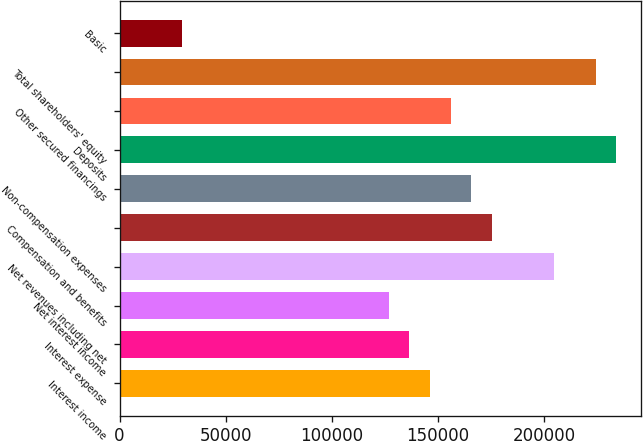<chart> <loc_0><loc_0><loc_500><loc_500><bar_chart><fcel>Interest income<fcel>Interest expense<fcel>Net interest income<fcel>Net revenues including net<fcel>Compensation and benefits<fcel>Non-compensation expenses<fcel>Deposits<fcel>Other secured financings<fcel>Total shareholders' equity<fcel>Basic<nl><fcel>146277<fcel>136526<fcel>126774<fcel>204787<fcel>175532<fcel>165780<fcel>234042<fcel>156029<fcel>224290<fcel>29257.5<nl></chart> 